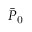Convert formula to latex. <formula><loc_0><loc_0><loc_500><loc_500>\bar { P } _ { 0 }</formula> 